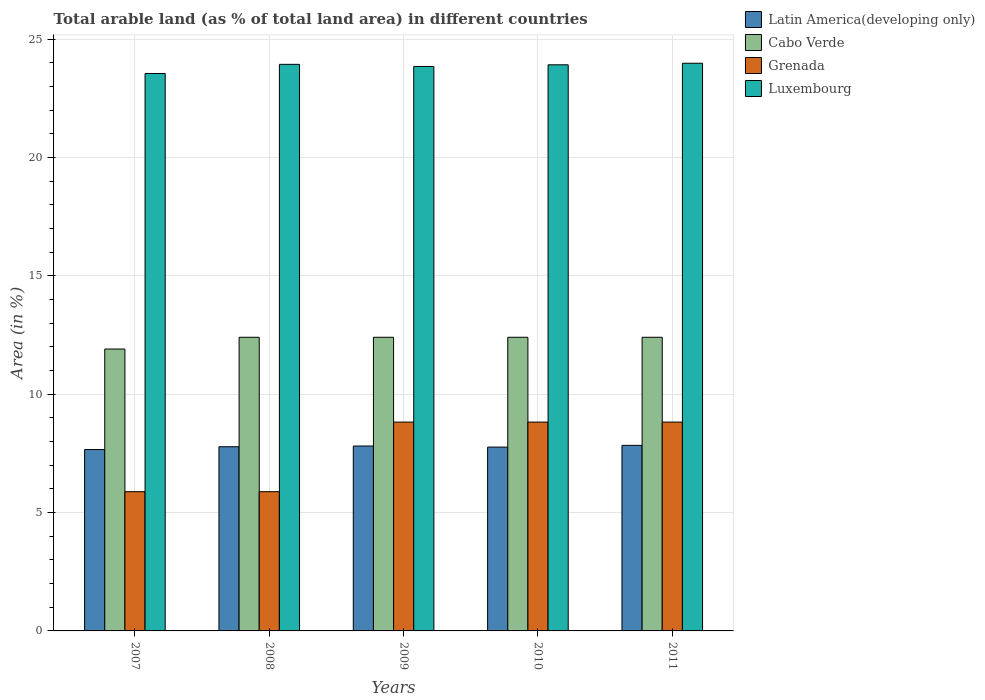Are the number of bars per tick equal to the number of legend labels?
Offer a terse response. Yes. Are the number of bars on each tick of the X-axis equal?
Keep it short and to the point. Yes. How many bars are there on the 2nd tick from the left?
Your answer should be compact. 4. How many bars are there on the 3rd tick from the right?
Your response must be concise. 4. What is the percentage of arable land in Luxembourg in 2007?
Keep it short and to the point. 23.55. Across all years, what is the maximum percentage of arable land in Grenada?
Give a very brief answer. 8.82. Across all years, what is the minimum percentage of arable land in Cabo Verde?
Provide a short and direct response. 11.91. What is the total percentage of arable land in Latin America(developing only) in the graph?
Make the answer very short. 38.86. What is the difference between the percentage of arable land in Luxembourg in 2009 and that in 2010?
Make the answer very short. -0.07. What is the difference between the percentage of arable land in Grenada in 2007 and the percentage of arable land in Cabo Verde in 2010?
Offer a terse response. -6.52. What is the average percentage of arable land in Cabo Verde per year?
Keep it short and to the point. 12.31. In the year 2008, what is the difference between the percentage of arable land in Latin America(developing only) and percentage of arable land in Cabo Verde?
Make the answer very short. -4.62. What is the ratio of the percentage of arable land in Luxembourg in 2007 to that in 2010?
Provide a succinct answer. 0.98. Is the percentage of arable land in Latin America(developing only) in 2008 less than that in 2009?
Make the answer very short. Yes. What is the difference between the highest and the lowest percentage of arable land in Latin America(developing only)?
Your answer should be very brief. 0.18. What does the 4th bar from the left in 2007 represents?
Your answer should be very brief. Luxembourg. What does the 2nd bar from the right in 2011 represents?
Your answer should be very brief. Grenada. Is it the case that in every year, the sum of the percentage of arable land in Luxembourg and percentage of arable land in Latin America(developing only) is greater than the percentage of arable land in Grenada?
Your answer should be compact. Yes. Are all the bars in the graph horizontal?
Provide a short and direct response. No. Does the graph contain grids?
Your answer should be compact. Yes. How many legend labels are there?
Your response must be concise. 4. What is the title of the graph?
Offer a very short reply. Total arable land (as % of total land area) in different countries. What is the label or title of the Y-axis?
Your response must be concise. Area (in %). What is the Area (in %) of Latin America(developing only) in 2007?
Give a very brief answer. 7.66. What is the Area (in %) in Cabo Verde in 2007?
Your response must be concise. 11.91. What is the Area (in %) of Grenada in 2007?
Your response must be concise. 5.88. What is the Area (in %) in Luxembourg in 2007?
Make the answer very short. 23.55. What is the Area (in %) in Latin America(developing only) in 2008?
Give a very brief answer. 7.78. What is the Area (in %) in Cabo Verde in 2008?
Give a very brief answer. 12.41. What is the Area (in %) in Grenada in 2008?
Offer a very short reply. 5.88. What is the Area (in %) of Luxembourg in 2008?
Offer a very short reply. 23.94. What is the Area (in %) of Latin America(developing only) in 2009?
Offer a terse response. 7.81. What is the Area (in %) of Cabo Verde in 2009?
Provide a succinct answer. 12.41. What is the Area (in %) in Grenada in 2009?
Ensure brevity in your answer.  8.82. What is the Area (in %) of Luxembourg in 2009?
Give a very brief answer. 23.85. What is the Area (in %) in Latin America(developing only) in 2010?
Provide a succinct answer. 7.77. What is the Area (in %) in Cabo Verde in 2010?
Offer a terse response. 12.41. What is the Area (in %) in Grenada in 2010?
Offer a terse response. 8.82. What is the Area (in %) of Luxembourg in 2010?
Offer a very short reply. 23.92. What is the Area (in %) in Latin America(developing only) in 2011?
Keep it short and to the point. 7.84. What is the Area (in %) in Cabo Verde in 2011?
Offer a terse response. 12.41. What is the Area (in %) in Grenada in 2011?
Offer a terse response. 8.82. What is the Area (in %) of Luxembourg in 2011?
Your response must be concise. 23.98. Across all years, what is the maximum Area (in %) of Latin America(developing only)?
Ensure brevity in your answer.  7.84. Across all years, what is the maximum Area (in %) in Cabo Verde?
Offer a very short reply. 12.41. Across all years, what is the maximum Area (in %) of Grenada?
Make the answer very short. 8.82. Across all years, what is the maximum Area (in %) of Luxembourg?
Your response must be concise. 23.98. Across all years, what is the minimum Area (in %) in Latin America(developing only)?
Make the answer very short. 7.66. Across all years, what is the minimum Area (in %) in Cabo Verde?
Your response must be concise. 11.91. Across all years, what is the minimum Area (in %) of Grenada?
Ensure brevity in your answer.  5.88. Across all years, what is the minimum Area (in %) in Luxembourg?
Make the answer very short. 23.55. What is the total Area (in %) of Latin America(developing only) in the graph?
Your answer should be very brief. 38.86. What is the total Area (in %) of Cabo Verde in the graph?
Your answer should be compact. 61.54. What is the total Area (in %) in Grenada in the graph?
Keep it short and to the point. 38.24. What is the total Area (in %) in Luxembourg in the graph?
Your answer should be very brief. 119.24. What is the difference between the Area (in %) of Latin America(developing only) in 2007 and that in 2008?
Ensure brevity in your answer.  -0.12. What is the difference between the Area (in %) in Cabo Verde in 2007 and that in 2008?
Offer a terse response. -0.5. What is the difference between the Area (in %) of Luxembourg in 2007 and that in 2008?
Make the answer very short. -0.39. What is the difference between the Area (in %) in Latin America(developing only) in 2007 and that in 2009?
Ensure brevity in your answer.  -0.15. What is the difference between the Area (in %) in Cabo Verde in 2007 and that in 2009?
Your response must be concise. -0.5. What is the difference between the Area (in %) of Grenada in 2007 and that in 2009?
Your answer should be very brief. -2.94. What is the difference between the Area (in %) of Luxembourg in 2007 and that in 2009?
Keep it short and to the point. -0.3. What is the difference between the Area (in %) in Latin America(developing only) in 2007 and that in 2010?
Make the answer very short. -0.1. What is the difference between the Area (in %) of Cabo Verde in 2007 and that in 2010?
Your answer should be very brief. -0.5. What is the difference between the Area (in %) in Grenada in 2007 and that in 2010?
Provide a succinct answer. -2.94. What is the difference between the Area (in %) of Luxembourg in 2007 and that in 2010?
Your response must be concise. -0.37. What is the difference between the Area (in %) of Latin America(developing only) in 2007 and that in 2011?
Provide a succinct answer. -0.18. What is the difference between the Area (in %) in Cabo Verde in 2007 and that in 2011?
Offer a terse response. -0.5. What is the difference between the Area (in %) in Grenada in 2007 and that in 2011?
Make the answer very short. -2.94. What is the difference between the Area (in %) in Luxembourg in 2007 and that in 2011?
Ensure brevity in your answer.  -0.43. What is the difference between the Area (in %) in Latin America(developing only) in 2008 and that in 2009?
Keep it short and to the point. -0.03. What is the difference between the Area (in %) in Cabo Verde in 2008 and that in 2009?
Offer a terse response. 0. What is the difference between the Area (in %) in Grenada in 2008 and that in 2009?
Offer a very short reply. -2.94. What is the difference between the Area (in %) in Luxembourg in 2008 and that in 2009?
Offer a very short reply. 0.09. What is the difference between the Area (in %) of Latin America(developing only) in 2008 and that in 2010?
Your answer should be very brief. 0.02. What is the difference between the Area (in %) in Grenada in 2008 and that in 2010?
Your answer should be compact. -2.94. What is the difference between the Area (in %) of Luxembourg in 2008 and that in 2010?
Give a very brief answer. 0.02. What is the difference between the Area (in %) of Latin America(developing only) in 2008 and that in 2011?
Ensure brevity in your answer.  -0.06. What is the difference between the Area (in %) of Cabo Verde in 2008 and that in 2011?
Offer a very short reply. 0. What is the difference between the Area (in %) of Grenada in 2008 and that in 2011?
Make the answer very short. -2.94. What is the difference between the Area (in %) in Luxembourg in 2008 and that in 2011?
Offer a terse response. -0.05. What is the difference between the Area (in %) in Latin America(developing only) in 2009 and that in 2010?
Ensure brevity in your answer.  0.05. What is the difference between the Area (in %) of Cabo Verde in 2009 and that in 2010?
Give a very brief answer. 0. What is the difference between the Area (in %) in Luxembourg in 2009 and that in 2010?
Your answer should be compact. -0.07. What is the difference between the Area (in %) in Latin America(developing only) in 2009 and that in 2011?
Make the answer very short. -0.03. What is the difference between the Area (in %) in Cabo Verde in 2009 and that in 2011?
Offer a terse response. 0. What is the difference between the Area (in %) in Luxembourg in 2009 and that in 2011?
Make the answer very short. -0.14. What is the difference between the Area (in %) in Latin America(developing only) in 2010 and that in 2011?
Provide a succinct answer. -0.07. What is the difference between the Area (in %) in Cabo Verde in 2010 and that in 2011?
Your response must be concise. 0. What is the difference between the Area (in %) of Grenada in 2010 and that in 2011?
Your response must be concise. 0. What is the difference between the Area (in %) in Luxembourg in 2010 and that in 2011?
Offer a terse response. -0.07. What is the difference between the Area (in %) of Latin America(developing only) in 2007 and the Area (in %) of Cabo Verde in 2008?
Provide a succinct answer. -4.74. What is the difference between the Area (in %) in Latin America(developing only) in 2007 and the Area (in %) in Grenada in 2008?
Your answer should be compact. 1.78. What is the difference between the Area (in %) of Latin America(developing only) in 2007 and the Area (in %) of Luxembourg in 2008?
Your answer should be compact. -16.28. What is the difference between the Area (in %) of Cabo Verde in 2007 and the Area (in %) of Grenada in 2008?
Ensure brevity in your answer.  6.03. What is the difference between the Area (in %) in Cabo Verde in 2007 and the Area (in %) in Luxembourg in 2008?
Make the answer very short. -12.03. What is the difference between the Area (in %) of Grenada in 2007 and the Area (in %) of Luxembourg in 2008?
Your answer should be very brief. -18.06. What is the difference between the Area (in %) in Latin America(developing only) in 2007 and the Area (in %) in Cabo Verde in 2009?
Give a very brief answer. -4.74. What is the difference between the Area (in %) in Latin America(developing only) in 2007 and the Area (in %) in Grenada in 2009?
Your response must be concise. -1.16. What is the difference between the Area (in %) in Latin America(developing only) in 2007 and the Area (in %) in Luxembourg in 2009?
Your answer should be very brief. -16.19. What is the difference between the Area (in %) in Cabo Verde in 2007 and the Area (in %) in Grenada in 2009?
Your response must be concise. 3.09. What is the difference between the Area (in %) of Cabo Verde in 2007 and the Area (in %) of Luxembourg in 2009?
Provide a short and direct response. -11.94. What is the difference between the Area (in %) of Grenada in 2007 and the Area (in %) of Luxembourg in 2009?
Keep it short and to the point. -17.97. What is the difference between the Area (in %) in Latin America(developing only) in 2007 and the Area (in %) in Cabo Verde in 2010?
Your response must be concise. -4.74. What is the difference between the Area (in %) in Latin America(developing only) in 2007 and the Area (in %) in Grenada in 2010?
Your answer should be very brief. -1.16. What is the difference between the Area (in %) of Latin America(developing only) in 2007 and the Area (in %) of Luxembourg in 2010?
Offer a very short reply. -16.26. What is the difference between the Area (in %) in Cabo Verde in 2007 and the Area (in %) in Grenada in 2010?
Provide a short and direct response. 3.09. What is the difference between the Area (in %) in Cabo Verde in 2007 and the Area (in %) in Luxembourg in 2010?
Provide a short and direct response. -12.01. What is the difference between the Area (in %) of Grenada in 2007 and the Area (in %) of Luxembourg in 2010?
Offer a terse response. -18.04. What is the difference between the Area (in %) of Latin America(developing only) in 2007 and the Area (in %) of Cabo Verde in 2011?
Offer a very short reply. -4.74. What is the difference between the Area (in %) of Latin America(developing only) in 2007 and the Area (in %) of Grenada in 2011?
Offer a very short reply. -1.16. What is the difference between the Area (in %) in Latin America(developing only) in 2007 and the Area (in %) in Luxembourg in 2011?
Make the answer very short. -16.32. What is the difference between the Area (in %) of Cabo Verde in 2007 and the Area (in %) of Grenada in 2011?
Your answer should be compact. 3.09. What is the difference between the Area (in %) in Cabo Verde in 2007 and the Area (in %) in Luxembourg in 2011?
Your response must be concise. -12.07. What is the difference between the Area (in %) in Grenada in 2007 and the Area (in %) in Luxembourg in 2011?
Offer a very short reply. -18.1. What is the difference between the Area (in %) of Latin America(developing only) in 2008 and the Area (in %) of Cabo Verde in 2009?
Keep it short and to the point. -4.62. What is the difference between the Area (in %) in Latin America(developing only) in 2008 and the Area (in %) in Grenada in 2009?
Your answer should be very brief. -1.04. What is the difference between the Area (in %) of Latin America(developing only) in 2008 and the Area (in %) of Luxembourg in 2009?
Offer a terse response. -16.07. What is the difference between the Area (in %) of Cabo Verde in 2008 and the Area (in %) of Grenada in 2009?
Make the answer very short. 3.58. What is the difference between the Area (in %) of Cabo Verde in 2008 and the Area (in %) of Luxembourg in 2009?
Provide a short and direct response. -11.44. What is the difference between the Area (in %) of Grenada in 2008 and the Area (in %) of Luxembourg in 2009?
Give a very brief answer. -17.97. What is the difference between the Area (in %) of Latin America(developing only) in 2008 and the Area (in %) of Cabo Verde in 2010?
Provide a succinct answer. -4.62. What is the difference between the Area (in %) in Latin America(developing only) in 2008 and the Area (in %) in Grenada in 2010?
Offer a terse response. -1.04. What is the difference between the Area (in %) in Latin America(developing only) in 2008 and the Area (in %) in Luxembourg in 2010?
Your answer should be compact. -16.14. What is the difference between the Area (in %) in Cabo Verde in 2008 and the Area (in %) in Grenada in 2010?
Provide a succinct answer. 3.58. What is the difference between the Area (in %) of Cabo Verde in 2008 and the Area (in %) of Luxembourg in 2010?
Give a very brief answer. -11.51. What is the difference between the Area (in %) of Grenada in 2008 and the Area (in %) of Luxembourg in 2010?
Ensure brevity in your answer.  -18.04. What is the difference between the Area (in %) in Latin America(developing only) in 2008 and the Area (in %) in Cabo Verde in 2011?
Keep it short and to the point. -4.62. What is the difference between the Area (in %) in Latin America(developing only) in 2008 and the Area (in %) in Grenada in 2011?
Provide a short and direct response. -1.04. What is the difference between the Area (in %) of Latin America(developing only) in 2008 and the Area (in %) of Luxembourg in 2011?
Provide a succinct answer. -16.2. What is the difference between the Area (in %) of Cabo Verde in 2008 and the Area (in %) of Grenada in 2011?
Your response must be concise. 3.58. What is the difference between the Area (in %) of Cabo Verde in 2008 and the Area (in %) of Luxembourg in 2011?
Keep it short and to the point. -11.58. What is the difference between the Area (in %) in Grenada in 2008 and the Area (in %) in Luxembourg in 2011?
Your answer should be very brief. -18.1. What is the difference between the Area (in %) in Latin America(developing only) in 2009 and the Area (in %) in Cabo Verde in 2010?
Provide a short and direct response. -4.59. What is the difference between the Area (in %) of Latin America(developing only) in 2009 and the Area (in %) of Grenada in 2010?
Give a very brief answer. -1.01. What is the difference between the Area (in %) of Latin America(developing only) in 2009 and the Area (in %) of Luxembourg in 2010?
Make the answer very short. -16.11. What is the difference between the Area (in %) of Cabo Verde in 2009 and the Area (in %) of Grenada in 2010?
Ensure brevity in your answer.  3.58. What is the difference between the Area (in %) of Cabo Verde in 2009 and the Area (in %) of Luxembourg in 2010?
Provide a succinct answer. -11.51. What is the difference between the Area (in %) of Grenada in 2009 and the Area (in %) of Luxembourg in 2010?
Make the answer very short. -15.1. What is the difference between the Area (in %) of Latin America(developing only) in 2009 and the Area (in %) of Cabo Verde in 2011?
Make the answer very short. -4.59. What is the difference between the Area (in %) in Latin America(developing only) in 2009 and the Area (in %) in Grenada in 2011?
Provide a short and direct response. -1.01. What is the difference between the Area (in %) in Latin America(developing only) in 2009 and the Area (in %) in Luxembourg in 2011?
Your answer should be compact. -16.17. What is the difference between the Area (in %) in Cabo Verde in 2009 and the Area (in %) in Grenada in 2011?
Your answer should be very brief. 3.58. What is the difference between the Area (in %) of Cabo Verde in 2009 and the Area (in %) of Luxembourg in 2011?
Keep it short and to the point. -11.58. What is the difference between the Area (in %) of Grenada in 2009 and the Area (in %) of Luxembourg in 2011?
Make the answer very short. -15.16. What is the difference between the Area (in %) in Latin America(developing only) in 2010 and the Area (in %) in Cabo Verde in 2011?
Your answer should be very brief. -4.64. What is the difference between the Area (in %) in Latin America(developing only) in 2010 and the Area (in %) in Grenada in 2011?
Provide a short and direct response. -1.06. What is the difference between the Area (in %) of Latin America(developing only) in 2010 and the Area (in %) of Luxembourg in 2011?
Your answer should be compact. -16.22. What is the difference between the Area (in %) of Cabo Verde in 2010 and the Area (in %) of Grenada in 2011?
Provide a succinct answer. 3.58. What is the difference between the Area (in %) in Cabo Verde in 2010 and the Area (in %) in Luxembourg in 2011?
Provide a succinct answer. -11.58. What is the difference between the Area (in %) of Grenada in 2010 and the Area (in %) of Luxembourg in 2011?
Your answer should be compact. -15.16. What is the average Area (in %) in Latin America(developing only) per year?
Your answer should be very brief. 7.77. What is the average Area (in %) of Cabo Verde per year?
Provide a succinct answer. 12.31. What is the average Area (in %) in Grenada per year?
Make the answer very short. 7.65. What is the average Area (in %) in Luxembourg per year?
Keep it short and to the point. 23.85. In the year 2007, what is the difference between the Area (in %) of Latin America(developing only) and Area (in %) of Cabo Verde?
Your answer should be very brief. -4.25. In the year 2007, what is the difference between the Area (in %) of Latin America(developing only) and Area (in %) of Grenada?
Ensure brevity in your answer.  1.78. In the year 2007, what is the difference between the Area (in %) of Latin America(developing only) and Area (in %) of Luxembourg?
Provide a succinct answer. -15.89. In the year 2007, what is the difference between the Area (in %) of Cabo Verde and Area (in %) of Grenada?
Ensure brevity in your answer.  6.03. In the year 2007, what is the difference between the Area (in %) in Cabo Verde and Area (in %) in Luxembourg?
Your answer should be very brief. -11.64. In the year 2007, what is the difference between the Area (in %) in Grenada and Area (in %) in Luxembourg?
Make the answer very short. -17.67. In the year 2008, what is the difference between the Area (in %) in Latin America(developing only) and Area (in %) in Cabo Verde?
Provide a short and direct response. -4.62. In the year 2008, what is the difference between the Area (in %) of Latin America(developing only) and Area (in %) of Grenada?
Your answer should be compact. 1.9. In the year 2008, what is the difference between the Area (in %) of Latin America(developing only) and Area (in %) of Luxembourg?
Your response must be concise. -16.16. In the year 2008, what is the difference between the Area (in %) of Cabo Verde and Area (in %) of Grenada?
Your response must be concise. 6.52. In the year 2008, what is the difference between the Area (in %) of Cabo Verde and Area (in %) of Luxembourg?
Provide a succinct answer. -11.53. In the year 2008, what is the difference between the Area (in %) of Grenada and Area (in %) of Luxembourg?
Keep it short and to the point. -18.06. In the year 2009, what is the difference between the Area (in %) in Latin America(developing only) and Area (in %) in Cabo Verde?
Offer a terse response. -4.59. In the year 2009, what is the difference between the Area (in %) of Latin America(developing only) and Area (in %) of Grenada?
Give a very brief answer. -1.01. In the year 2009, what is the difference between the Area (in %) of Latin America(developing only) and Area (in %) of Luxembourg?
Keep it short and to the point. -16.04. In the year 2009, what is the difference between the Area (in %) of Cabo Verde and Area (in %) of Grenada?
Your answer should be very brief. 3.58. In the year 2009, what is the difference between the Area (in %) of Cabo Verde and Area (in %) of Luxembourg?
Offer a terse response. -11.44. In the year 2009, what is the difference between the Area (in %) of Grenada and Area (in %) of Luxembourg?
Make the answer very short. -15.03. In the year 2010, what is the difference between the Area (in %) in Latin America(developing only) and Area (in %) in Cabo Verde?
Your response must be concise. -4.64. In the year 2010, what is the difference between the Area (in %) in Latin America(developing only) and Area (in %) in Grenada?
Keep it short and to the point. -1.06. In the year 2010, what is the difference between the Area (in %) of Latin America(developing only) and Area (in %) of Luxembourg?
Your response must be concise. -16.15. In the year 2010, what is the difference between the Area (in %) of Cabo Verde and Area (in %) of Grenada?
Offer a terse response. 3.58. In the year 2010, what is the difference between the Area (in %) of Cabo Verde and Area (in %) of Luxembourg?
Provide a short and direct response. -11.51. In the year 2010, what is the difference between the Area (in %) of Grenada and Area (in %) of Luxembourg?
Ensure brevity in your answer.  -15.1. In the year 2011, what is the difference between the Area (in %) in Latin America(developing only) and Area (in %) in Cabo Verde?
Keep it short and to the point. -4.57. In the year 2011, what is the difference between the Area (in %) in Latin America(developing only) and Area (in %) in Grenada?
Make the answer very short. -0.98. In the year 2011, what is the difference between the Area (in %) of Latin America(developing only) and Area (in %) of Luxembourg?
Your response must be concise. -16.14. In the year 2011, what is the difference between the Area (in %) in Cabo Verde and Area (in %) in Grenada?
Your answer should be very brief. 3.58. In the year 2011, what is the difference between the Area (in %) of Cabo Verde and Area (in %) of Luxembourg?
Your answer should be compact. -11.58. In the year 2011, what is the difference between the Area (in %) in Grenada and Area (in %) in Luxembourg?
Ensure brevity in your answer.  -15.16. What is the ratio of the Area (in %) in Latin America(developing only) in 2007 to that in 2008?
Provide a succinct answer. 0.98. What is the ratio of the Area (in %) of Luxembourg in 2007 to that in 2008?
Your response must be concise. 0.98. What is the ratio of the Area (in %) of Latin America(developing only) in 2007 to that in 2009?
Offer a very short reply. 0.98. What is the ratio of the Area (in %) in Cabo Verde in 2007 to that in 2009?
Provide a short and direct response. 0.96. What is the ratio of the Area (in %) of Grenada in 2007 to that in 2009?
Your response must be concise. 0.67. What is the ratio of the Area (in %) in Luxembourg in 2007 to that in 2009?
Keep it short and to the point. 0.99. What is the ratio of the Area (in %) in Latin America(developing only) in 2007 to that in 2010?
Offer a terse response. 0.99. What is the ratio of the Area (in %) of Cabo Verde in 2007 to that in 2010?
Offer a very short reply. 0.96. What is the ratio of the Area (in %) of Luxembourg in 2007 to that in 2010?
Offer a very short reply. 0.98. What is the ratio of the Area (in %) of Latin America(developing only) in 2007 to that in 2011?
Provide a short and direct response. 0.98. What is the ratio of the Area (in %) in Cabo Verde in 2007 to that in 2011?
Your answer should be very brief. 0.96. What is the ratio of the Area (in %) of Grenada in 2008 to that in 2009?
Your response must be concise. 0.67. What is the ratio of the Area (in %) of Latin America(developing only) in 2008 to that in 2010?
Provide a succinct answer. 1. What is the ratio of the Area (in %) in Grenada in 2008 to that in 2010?
Provide a succinct answer. 0.67. What is the ratio of the Area (in %) of Latin America(developing only) in 2008 to that in 2011?
Your answer should be compact. 0.99. What is the ratio of the Area (in %) of Cabo Verde in 2008 to that in 2011?
Make the answer very short. 1. What is the ratio of the Area (in %) of Grenada in 2008 to that in 2011?
Give a very brief answer. 0.67. What is the ratio of the Area (in %) of Luxembourg in 2008 to that in 2011?
Offer a terse response. 1. What is the ratio of the Area (in %) of Latin America(developing only) in 2009 to that in 2010?
Your response must be concise. 1.01. What is the ratio of the Area (in %) in Cabo Verde in 2009 to that in 2010?
Provide a short and direct response. 1. What is the ratio of the Area (in %) of Grenada in 2009 to that in 2010?
Offer a terse response. 1. What is the ratio of the Area (in %) in Luxembourg in 2009 to that in 2010?
Your answer should be very brief. 1. What is the ratio of the Area (in %) in Latin America(developing only) in 2009 to that in 2011?
Provide a short and direct response. 1. What is the ratio of the Area (in %) of Latin America(developing only) in 2010 to that in 2011?
Your answer should be compact. 0.99. What is the ratio of the Area (in %) of Cabo Verde in 2010 to that in 2011?
Make the answer very short. 1. What is the ratio of the Area (in %) of Grenada in 2010 to that in 2011?
Offer a terse response. 1. What is the ratio of the Area (in %) in Luxembourg in 2010 to that in 2011?
Ensure brevity in your answer.  1. What is the difference between the highest and the second highest Area (in %) of Latin America(developing only)?
Ensure brevity in your answer.  0.03. What is the difference between the highest and the second highest Area (in %) in Cabo Verde?
Offer a very short reply. 0. What is the difference between the highest and the second highest Area (in %) of Grenada?
Give a very brief answer. 0. What is the difference between the highest and the second highest Area (in %) in Luxembourg?
Make the answer very short. 0.05. What is the difference between the highest and the lowest Area (in %) of Latin America(developing only)?
Offer a very short reply. 0.18. What is the difference between the highest and the lowest Area (in %) in Cabo Verde?
Your answer should be very brief. 0.5. What is the difference between the highest and the lowest Area (in %) in Grenada?
Your answer should be compact. 2.94. What is the difference between the highest and the lowest Area (in %) of Luxembourg?
Provide a short and direct response. 0.43. 